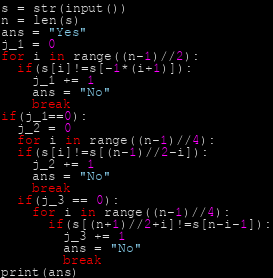<code> <loc_0><loc_0><loc_500><loc_500><_Python_>s = str(input())
n = len(s)
ans = "Yes"
j_1 = 0
for i in range((n-1)//2):
  if(s[i]!=s[-1*(i+1)]):
    j_1 += 1
    ans = "No"
    break
if(j_1==0):
  j_2 = 0
  for i in range((n-1)//4):
  if(s[i]!=s[(n-1)//2-i]):
    j_2 += 1
    ans = "No"
    break
  if(j_3 == 0):
    for i in range((n-1)//4):
      if(s[(n+1)//2+i]!=s[n-i-1]):
        j_3 += 1
        ans = "No"
        break
print(ans)</code> 